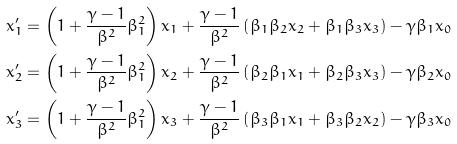<formula> <loc_0><loc_0><loc_500><loc_500>x _ { 1 } ^ { \prime } & = \left ( 1 + \frac { \gamma - 1 } { \beta ^ { 2 } } \beta _ { 1 } ^ { 2 } \right ) x _ { 1 } + \frac { \gamma - 1 } { \beta ^ { 2 } } \left ( \beta _ { 1 } \beta _ { 2 } x _ { 2 } + \beta _ { 1 } \beta _ { 3 } x _ { 3 } \right ) - \gamma \beta _ { 1 } x _ { 0 } \\ x _ { 2 } ^ { \prime } & = \left ( 1 + \frac { \gamma - 1 } { \beta ^ { 2 } } \beta _ { 1 } ^ { 2 } \right ) x _ { 2 } + \frac { \gamma - 1 } { \beta ^ { 2 } } \left ( \beta _ { 2 } \beta _ { 1 } x _ { 1 } + \beta _ { 2 } \beta _ { 3 } x _ { 3 } \right ) - \gamma \beta _ { 2 } x _ { 0 } \\ x _ { 3 } ^ { \prime } & = \left ( 1 + \frac { \gamma - 1 } { \beta ^ { 2 } } \beta _ { 1 } ^ { 2 } \right ) x _ { 3 } + \frac { \gamma - 1 } { \beta ^ { 2 } } \left ( \beta _ { 3 } \beta _ { 1 } x _ { 1 } + \beta _ { 3 } \beta _ { 2 } x _ { 2 } \right ) - \gamma \beta _ { 3 } x _ { 0 }</formula> 